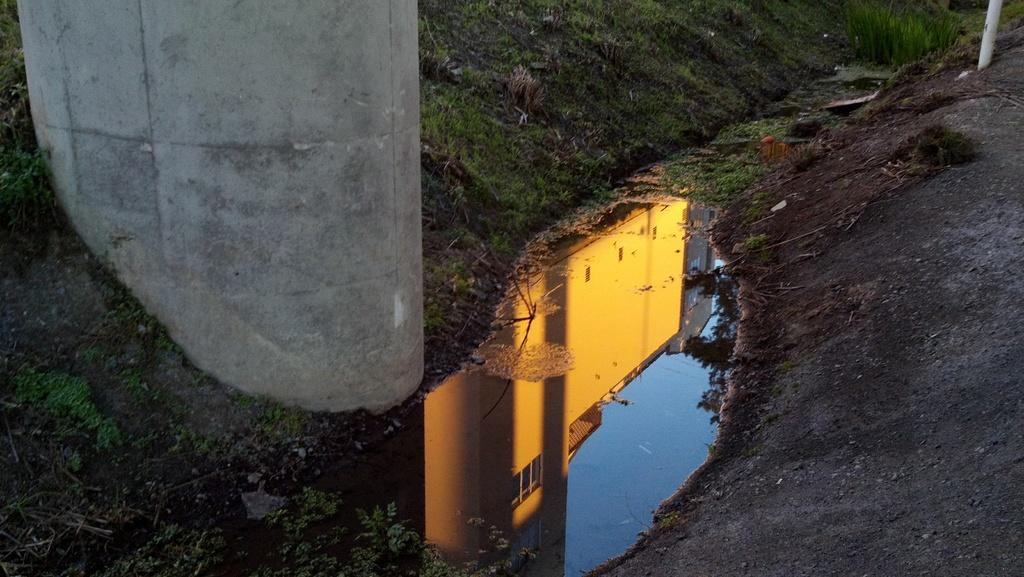What is the primary element visible in the image? There is water in the image. What structure can be seen in the image? There is a pole in the image. What type of vegetation is present in the image? There is grass in the image. What can be observed in the water in the image? Shadows of the sky, trees, and buildings are visible in the water. How many dimes are floating on the water in the image? There are no dimes visible in the image; it only features water, a pole, grass, and shadows in the water. 